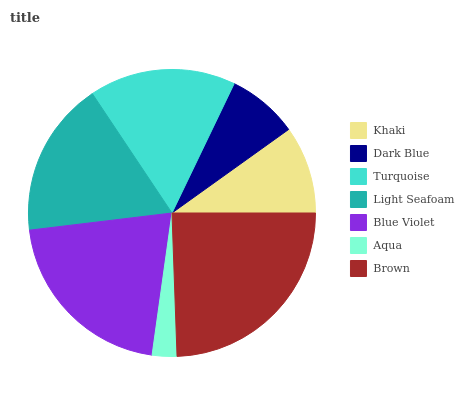Is Aqua the minimum?
Answer yes or no. Yes. Is Brown the maximum?
Answer yes or no. Yes. Is Dark Blue the minimum?
Answer yes or no. No. Is Dark Blue the maximum?
Answer yes or no. No. Is Khaki greater than Dark Blue?
Answer yes or no. Yes. Is Dark Blue less than Khaki?
Answer yes or no. Yes. Is Dark Blue greater than Khaki?
Answer yes or no. No. Is Khaki less than Dark Blue?
Answer yes or no. No. Is Turquoise the high median?
Answer yes or no. Yes. Is Turquoise the low median?
Answer yes or no. Yes. Is Brown the high median?
Answer yes or no. No. Is Khaki the low median?
Answer yes or no. No. 